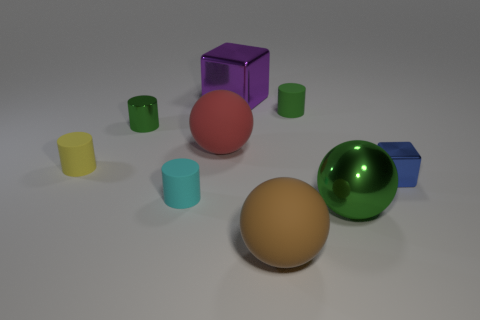What materials are the objects in the image made of? The objects look like they could be made of various materials: the colorful geometric solids could be made from a plastic or metal, judging by their shiny surfaces, whereas the yellow and light blue cylinders have a matte finish which might suggest they are made of rubber. 